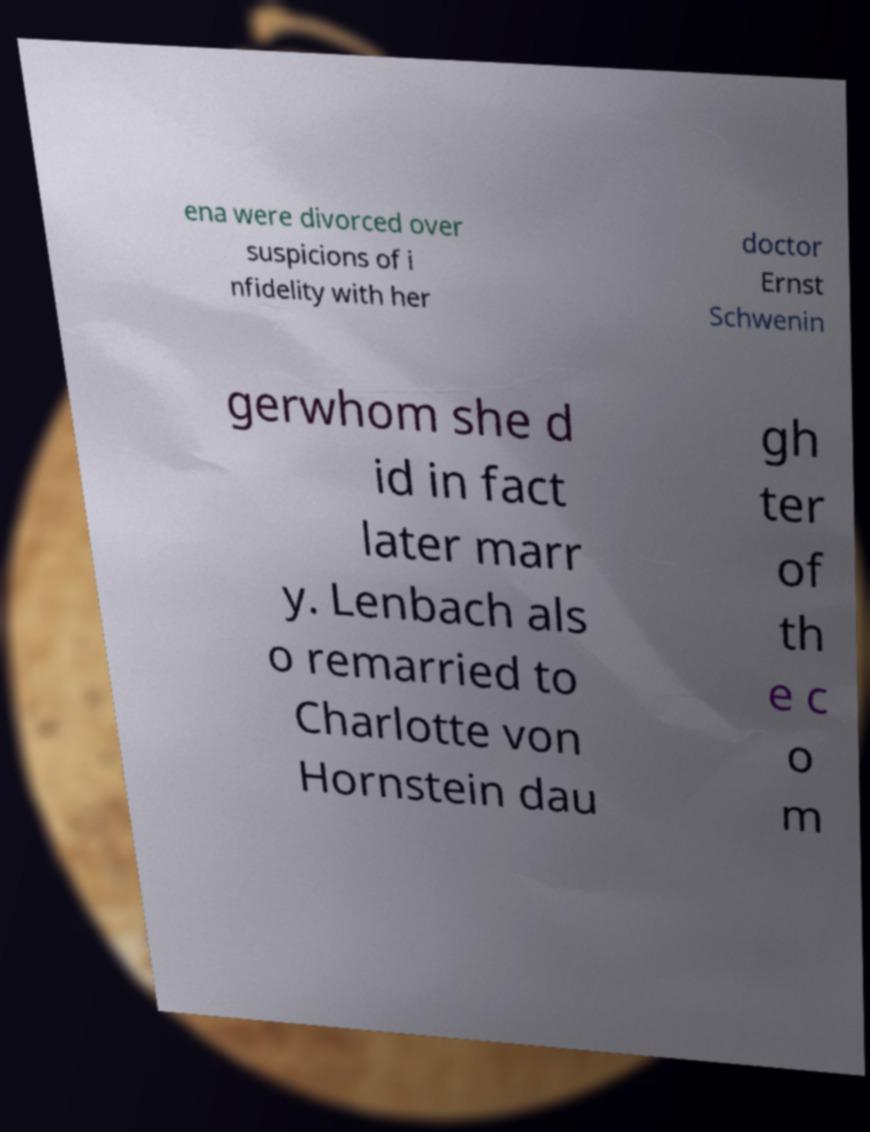Could you extract and type out the text from this image? ena were divorced over suspicions of i nfidelity with her doctor Ernst Schwenin gerwhom she d id in fact later marr y. Lenbach als o remarried to Charlotte von Hornstein dau gh ter of th e c o m 